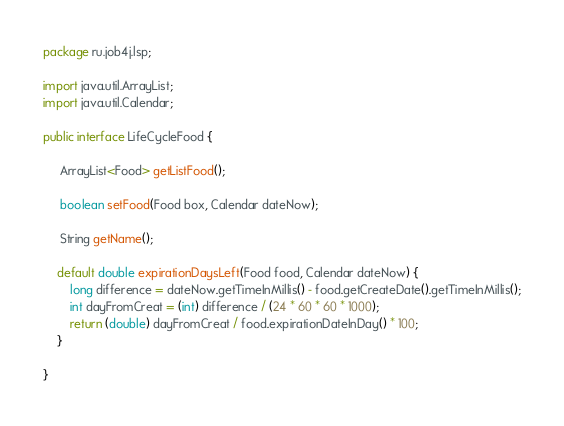Convert code to text. <code><loc_0><loc_0><loc_500><loc_500><_Java_>package ru.job4j.lsp;

import java.util.ArrayList;
import java.util.Calendar;

public interface LifeCycleFood {

     ArrayList<Food> getListFood();

     boolean setFood(Food box, Calendar dateNow);

     String getName();

    default double expirationDaysLeft(Food food, Calendar dateNow) {
        long difference = dateNow.getTimeInMillis() - food.getCreateDate().getTimeInMillis();
        int dayFromCreat = (int) difference / (24 * 60 * 60 * 1000);
        return (double) dayFromCreat / food.expirationDateInDay() * 100;
    }

}
</code> 